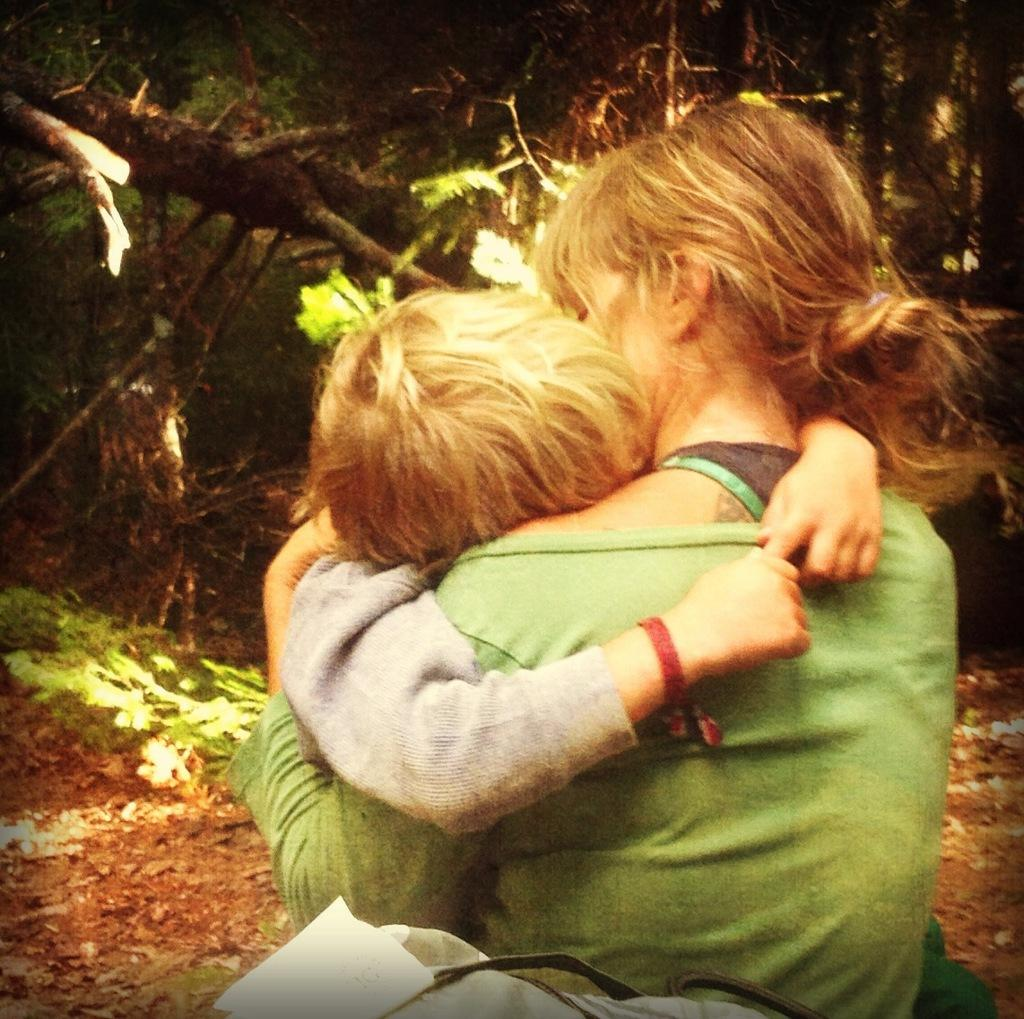What can be seen in the front of the image? There are persons sitting in the front of the image. What type of natural scenery is visible in the background of the image? There are trees in the background of the image. What type of note can be seen hanging from the tree in the image? There is no note hanging from the tree in the image; only trees are visible in the background. 